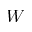<formula> <loc_0><loc_0><loc_500><loc_500>W</formula> 